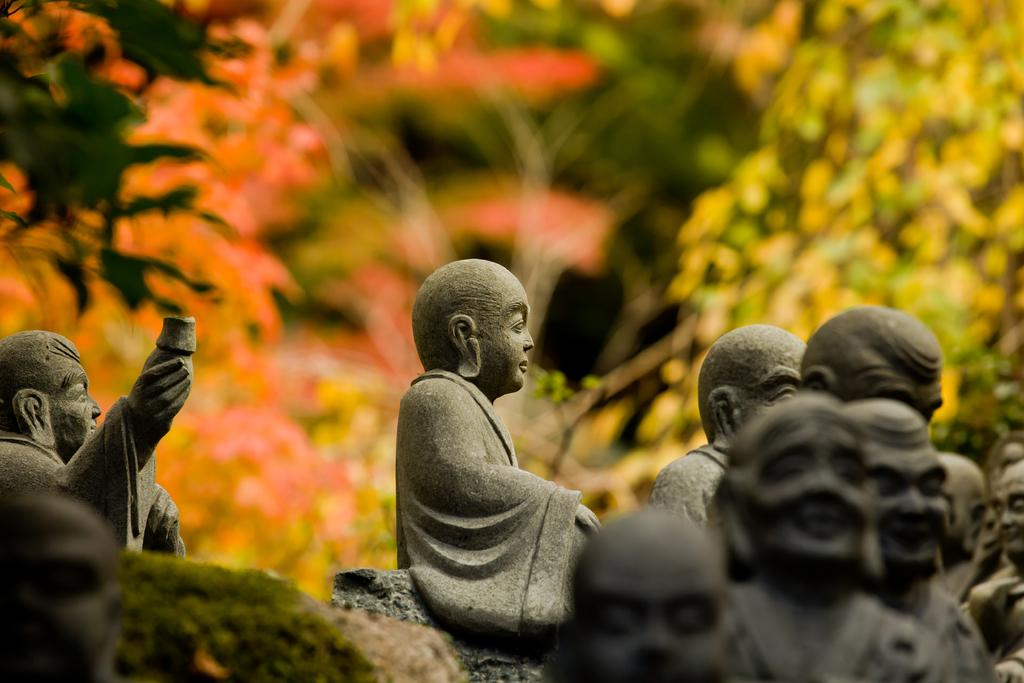What type of art is present in the image? There are sculptures in the image. What can be seen in the background of the image? There are trees in the background of the image. What type of structure is the man building in the image? There is no man or structure present in the image; it only features sculptures and trees. 